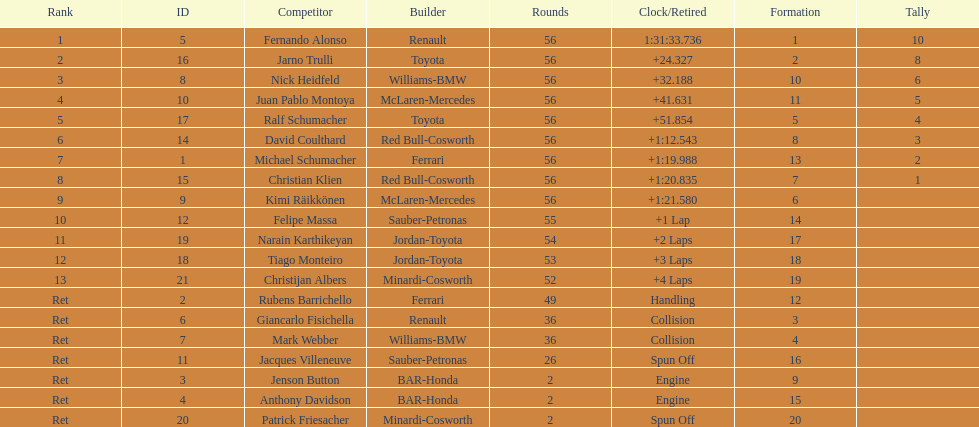How many drivers were retired before the race could end? 7. 